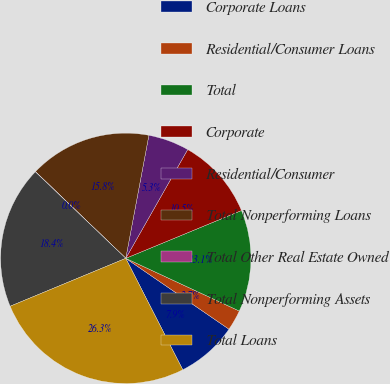<chart> <loc_0><loc_0><loc_500><loc_500><pie_chart><fcel>Corporate Loans<fcel>Residential/Consumer Loans<fcel>Total<fcel>Corporate<fcel>Residential/Consumer<fcel>Total Nonperforming Loans<fcel>Total Other Real Estate Owned<fcel>Total Nonperforming Assets<fcel>Total Loans<nl><fcel>7.9%<fcel>2.66%<fcel>13.15%<fcel>10.53%<fcel>5.28%<fcel>15.78%<fcel>0.03%<fcel>18.4%<fcel>26.27%<nl></chart> 